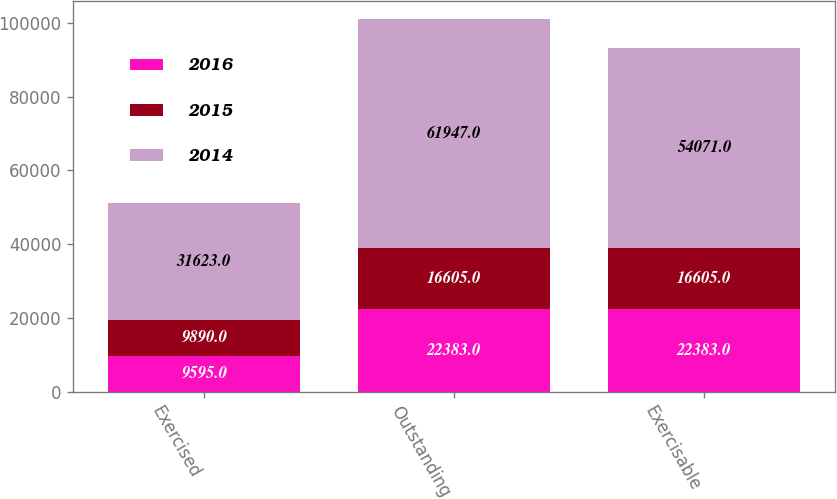Convert chart. <chart><loc_0><loc_0><loc_500><loc_500><stacked_bar_chart><ecel><fcel>Exercised<fcel>Outstanding<fcel>Exercisable<nl><fcel>2016<fcel>9595<fcel>22383<fcel>22383<nl><fcel>2015<fcel>9890<fcel>16605<fcel>16605<nl><fcel>2014<fcel>31623<fcel>61947<fcel>54071<nl></chart> 